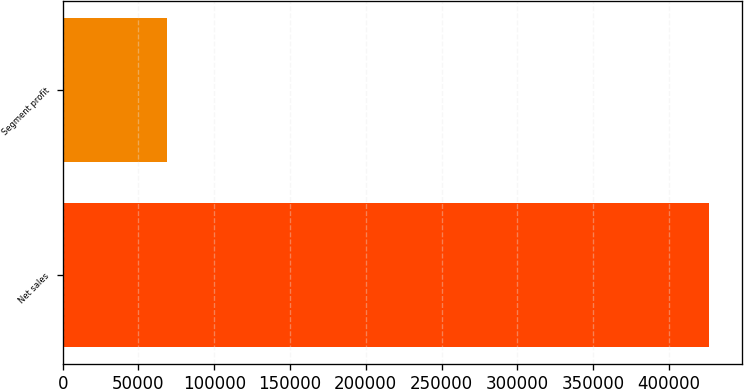<chart> <loc_0><loc_0><loc_500><loc_500><bar_chart><fcel>Net sales<fcel>Segment profit<nl><fcel>426680<fcel>68516<nl></chart> 